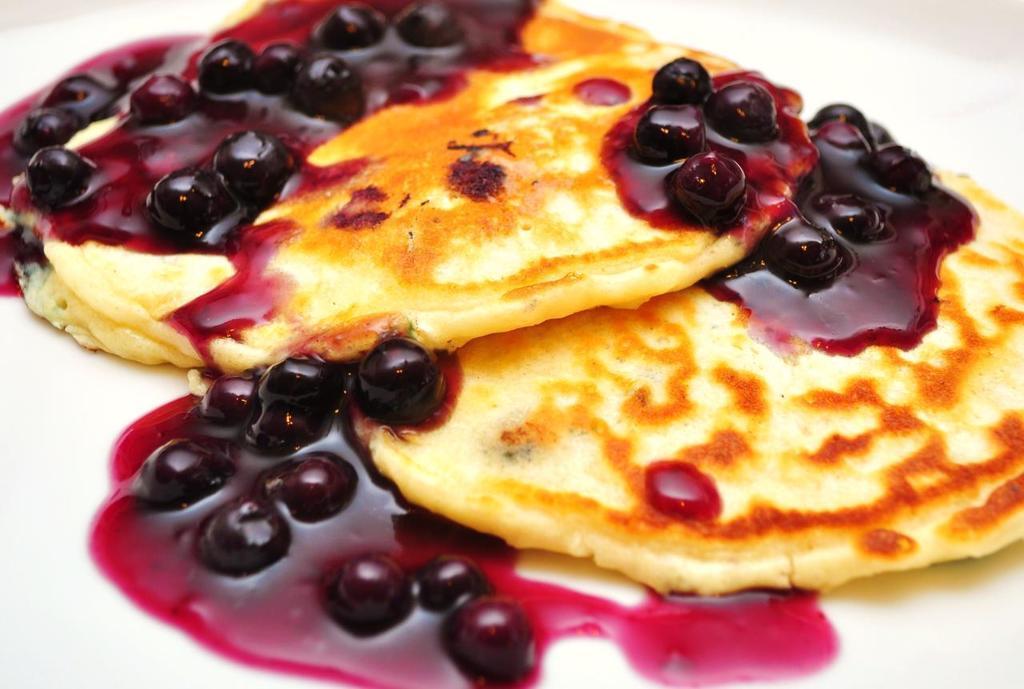Describe this image in one or two sentences. In this image, I can see two pancakes with the blueberry jam. The background looks white in color. 